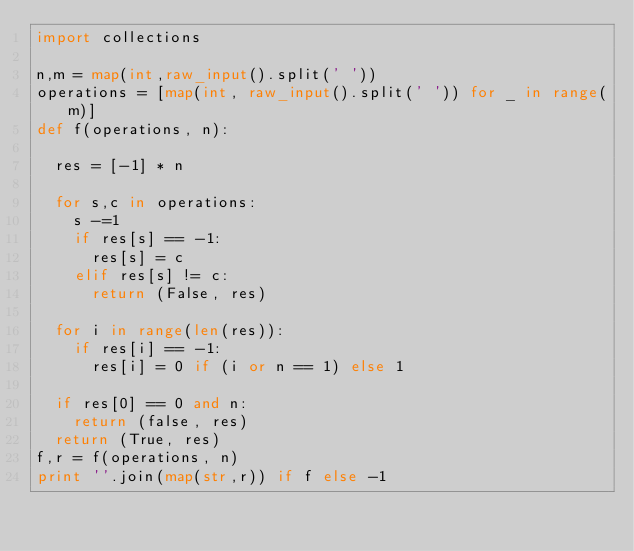Convert code to text. <code><loc_0><loc_0><loc_500><loc_500><_Python_>import collections

n,m = map(int,raw_input().split(' '))
operations = [map(int, raw_input().split(' ')) for _ in range(m)]
def f(operations, n):

	res = [-1] * n

	for s,c in operations:
		s -=1
		if res[s] == -1:
			res[s] = c
		elif res[s] != c:
			return (False, res)
	
	for i in range(len(res)):
		if res[i] == -1: 
			res[i] = 0 if (i or n == 1) else 1
	
	if res[0] == 0 and n:
		return (false, res)
	return (True, res)
f,r = f(operations, n)
print ''.join(map(str,r)) if f else -1</code> 